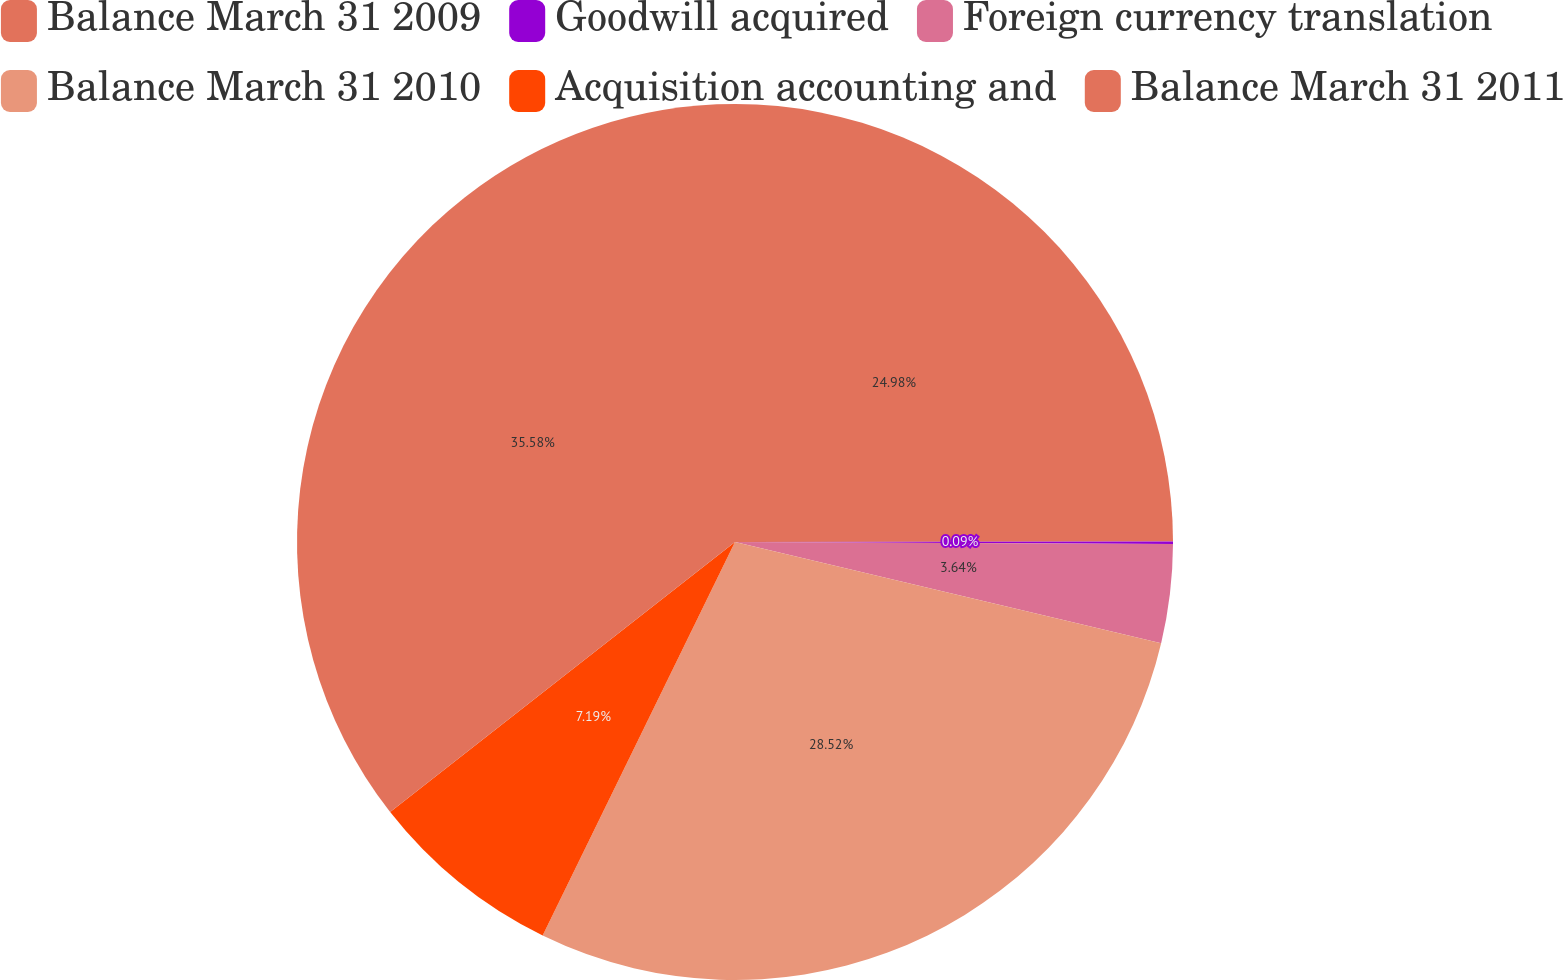Convert chart to OTSL. <chart><loc_0><loc_0><loc_500><loc_500><pie_chart><fcel>Balance March 31 2009<fcel>Goodwill acquired<fcel>Foreign currency translation<fcel>Balance March 31 2010<fcel>Acquisition accounting and<fcel>Balance March 31 2011<nl><fcel>24.98%<fcel>0.09%<fcel>3.64%<fcel>28.52%<fcel>7.19%<fcel>35.57%<nl></chart> 